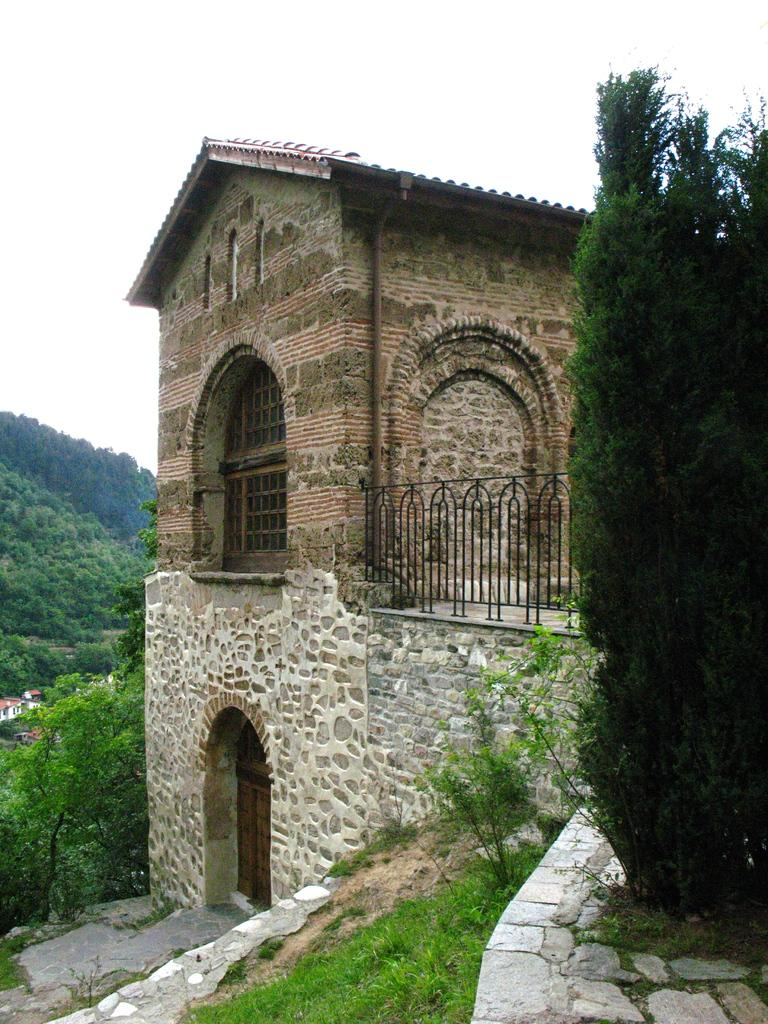What type of surface is visible in the image? There is grass on the surface in the image. What other types of vegetation can be seen in the image? There are plants and trees in the image. Are there any man-made structures visible in the image? Yes, there are buildings in the image. What is visible at the top of the image? The sky is visible at the top of the image. Can you see a crib in the image? No, there is no crib present in the image. How does the stream flow in the image? There is no stream present in the image. 